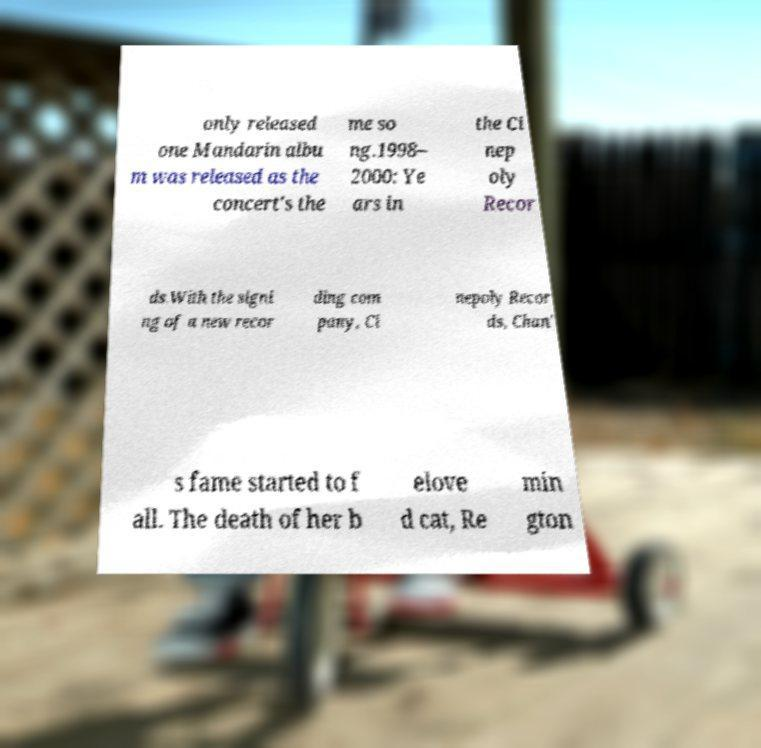Could you assist in decoding the text presented in this image and type it out clearly? only released one Mandarin albu m was released as the concert's the me so ng.1998– 2000: Ye ars in the Ci nep oly Recor ds.With the signi ng of a new recor ding com pany, Ci nepoly Recor ds, Chan' s fame started to f all. The death of her b elove d cat, Re min gton 